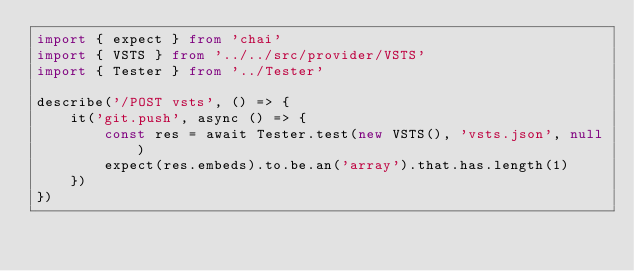Convert code to text. <code><loc_0><loc_0><loc_500><loc_500><_TypeScript_>import { expect } from 'chai'
import { VSTS } from '../../src/provider/VSTS'
import { Tester } from '../Tester'

describe('/POST vsts', () => {
    it('git.push', async () => {
        const res = await Tester.test(new VSTS(), 'vsts.json', null)
        expect(res.embeds).to.be.an('array').that.has.length(1)
    })
})
</code> 